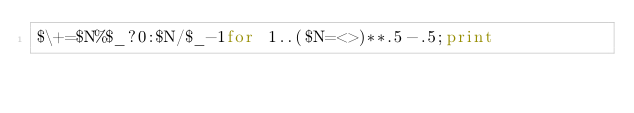<code> <loc_0><loc_0><loc_500><loc_500><_Perl_>$\+=$N%$_?0:$N/$_-1for 1..($N=<>)**.5-.5;print</code> 